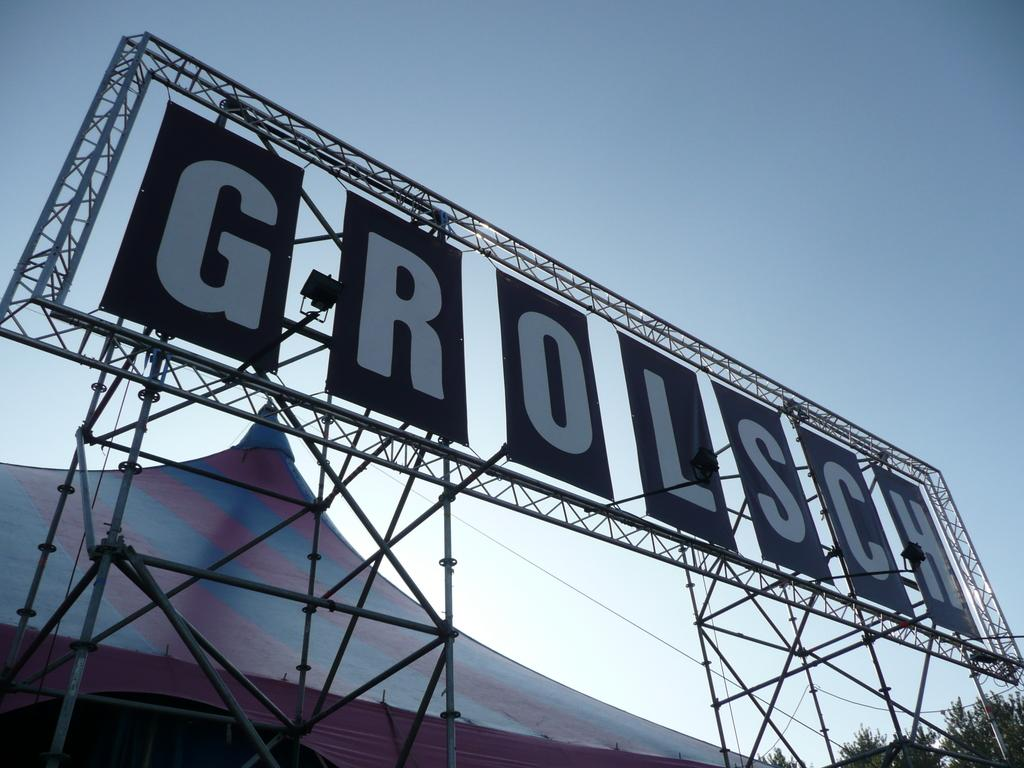<image>
Provide a brief description of the given image. a sign with the word GROLSCH on it 